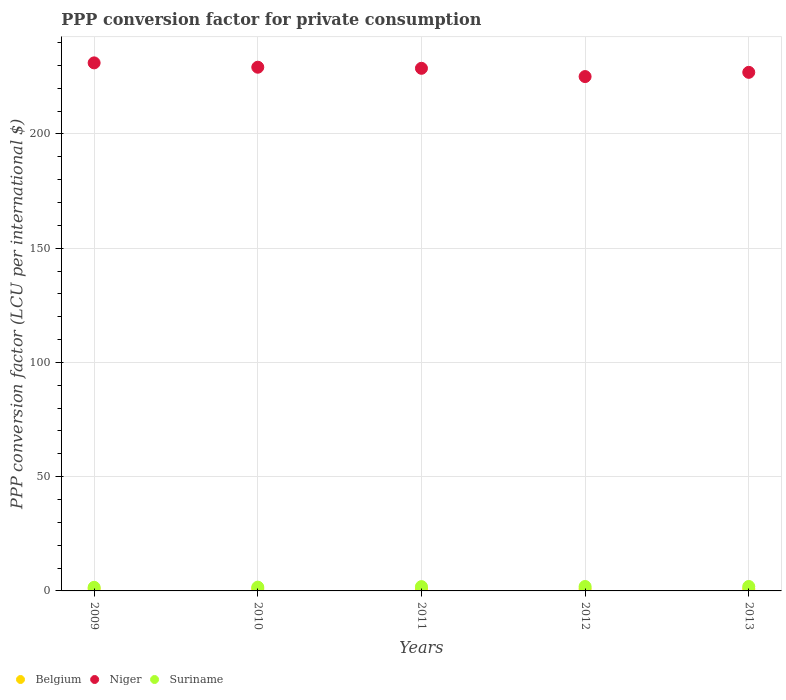Is the number of dotlines equal to the number of legend labels?
Your answer should be very brief. Yes. What is the PPP conversion factor for private consumption in Niger in 2012?
Offer a very short reply. 225.14. Across all years, what is the maximum PPP conversion factor for private consumption in Suriname?
Your answer should be very brief. 1.95. Across all years, what is the minimum PPP conversion factor for private consumption in Niger?
Your answer should be compact. 225.14. In which year was the PPP conversion factor for private consumption in Niger maximum?
Keep it short and to the point. 2009. What is the total PPP conversion factor for private consumption in Suriname in the graph?
Provide a short and direct response. 8.99. What is the difference between the PPP conversion factor for private consumption in Belgium in 2012 and that in 2013?
Ensure brevity in your answer.  -0.01. What is the difference between the PPP conversion factor for private consumption in Belgium in 2012 and the PPP conversion factor for private consumption in Niger in 2010?
Provide a succinct answer. -228.34. What is the average PPP conversion factor for private consumption in Suriname per year?
Offer a very short reply. 1.8. In the year 2011, what is the difference between the PPP conversion factor for private consumption in Belgium and PPP conversion factor for private consumption in Suriname?
Provide a short and direct response. -0.99. In how many years, is the PPP conversion factor for private consumption in Niger greater than 230 LCU?
Your answer should be very brief. 1. What is the ratio of the PPP conversion factor for private consumption in Belgium in 2009 to that in 2010?
Make the answer very short. 1. Is the PPP conversion factor for private consumption in Belgium in 2012 less than that in 2013?
Keep it short and to the point. Yes. Is the difference between the PPP conversion factor for private consumption in Belgium in 2009 and 2013 greater than the difference between the PPP conversion factor for private consumption in Suriname in 2009 and 2013?
Keep it short and to the point. Yes. What is the difference between the highest and the second highest PPP conversion factor for private consumption in Suriname?
Offer a very short reply. 0.01. What is the difference between the highest and the lowest PPP conversion factor for private consumption in Niger?
Keep it short and to the point. 6. In how many years, is the PPP conversion factor for private consumption in Niger greater than the average PPP conversion factor for private consumption in Niger taken over all years?
Your answer should be compact. 3. Is the sum of the PPP conversion factor for private consumption in Suriname in 2011 and 2013 greater than the maximum PPP conversion factor for private consumption in Belgium across all years?
Ensure brevity in your answer.  Yes. Is it the case that in every year, the sum of the PPP conversion factor for private consumption in Niger and PPP conversion factor for private consumption in Belgium  is greater than the PPP conversion factor for private consumption in Suriname?
Your answer should be compact. Yes. Does the PPP conversion factor for private consumption in Suriname monotonically increase over the years?
Your answer should be very brief. Yes. Is the PPP conversion factor for private consumption in Belgium strictly greater than the PPP conversion factor for private consumption in Suriname over the years?
Give a very brief answer. No. Is the PPP conversion factor for private consumption in Suriname strictly less than the PPP conversion factor for private consumption in Niger over the years?
Your answer should be compact. Yes. What is the difference between two consecutive major ticks on the Y-axis?
Give a very brief answer. 50. Are the values on the major ticks of Y-axis written in scientific E-notation?
Your answer should be compact. No. What is the title of the graph?
Keep it short and to the point. PPP conversion factor for private consumption. Does "World" appear as one of the legend labels in the graph?
Make the answer very short. No. What is the label or title of the Y-axis?
Offer a very short reply. PPP conversion factor (LCU per international $). What is the PPP conversion factor (LCU per international $) in Belgium in 2009?
Offer a terse response. 0.9. What is the PPP conversion factor (LCU per international $) in Niger in 2009?
Make the answer very short. 231.13. What is the PPP conversion factor (LCU per international $) of Suriname in 2009?
Keep it short and to the point. 1.57. What is the PPP conversion factor (LCU per international $) of Belgium in 2010?
Offer a terse response. 0.9. What is the PPP conversion factor (LCU per international $) in Niger in 2010?
Provide a succinct answer. 229.23. What is the PPP conversion factor (LCU per international $) in Suriname in 2010?
Your answer should be very brief. 1.65. What is the PPP conversion factor (LCU per international $) of Belgium in 2011?
Ensure brevity in your answer.  0.89. What is the PPP conversion factor (LCU per international $) in Niger in 2011?
Provide a short and direct response. 228.75. What is the PPP conversion factor (LCU per international $) of Suriname in 2011?
Provide a short and direct response. 1.88. What is the PPP conversion factor (LCU per international $) of Belgium in 2012?
Your answer should be very brief. 0.89. What is the PPP conversion factor (LCU per international $) of Niger in 2012?
Provide a succinct answer. 225.14. What is the PPP conversion factor (LCU per international $) of Suriname in 2012?
Your response must be concise. 1.94. What is the PPP conversion factor (LCU per international $) of Belgium in 2013?
Make the answer very short. 0.9. What is the PPP conversion factor (LCU per international $) of Niger in 2013?
Give a very brief answer. 226.99. What is the PPP conversion factor (LCU per international $) of Suriname in 2013?
Your response must be concise. 1.95. Across all years, what is the maximum PPP conversion factor (LCU per international $) in Belgium?
Provide a succinct answer. 0.9. Across all years, what is the maximum PPP conversion factor (LCU per international $) in Niger?
Keep it short and to the point. 231.13. Across all years, what is the maximum PPP conversion factor (LCU per international $) in Suriname?
Offer a terse response. 1.95. Across all years, what is the minimum PPP conversion factor (LCU per international $) in Belgium?
Your response must be concise. 0.89. Across all years, what is the minimum PPP conversion factor (LCU per international $) of Niger?
Offer a very short reply. 225.14. Across all years, what is the minimum PPP conversion factor (LCU per international $) of Suriname?
Keep it short and to the point. 1.57. What is the total PPP conversion factor (LCU per international $) of Belgium in the graph?
Your response must be concise. 4.48. What is the total PPP conversion factor (LCU per international $) of Niger in the graph?
Keep it short and to the point. 1141.23. What is the total PPP conversion factor (LCU per international $) of Suriname in the graph?
Your answer should be compact. 8.99. What is the difference between the PPP conversion factor (LCU per international $) of Belgium in 2009 and that in 2010?
Your answer should be compact. -0. What is the difference between the PPP conversion factor (LCU per international $) in Niger in 2009 and that in 2010?
Your response must be concise. 1.9. What is the difference between the PPP conversion factor (LCU per international $) in Suriname in 2009 and that in 2010?
Give a very brief answer. -0.08. What is the difference between the PPP conversion factor (LCU per international $) of Belgium in 2009 and that in 2011?
Offer a very short reply. 0.01. What is the difference between the PPP conversion factor (LCU per international $) of Niger in 2009 and that in 2011?
Make the answer very short. 2.38. What is the difference between the PPP conversion factor (LCU per international $) in Suriname in 2009 and that in 2011?
Offer a terse response. -0.32. What is the difference between the PPP conversion factor (LCU per international $) of Belgium in 2009 and that in 2012?
Offer a terse response. 0.01. What is the difference between the PPP conversion factor (LCU per international $) in Niger in 2009 and that in 2012?
Your response must be concise. 6. What is the difference between the PPP conversion factor (LCU per international $) in Suriname in 2009 and that in 2012?
Offer a very short reply. -0.37. What is the difference between the PPP conversion factor (LCU per international $) of Belgium in 2009 and that in 2013?
Offer a terse response. 0. What is the difference between the PPP conversion factor (LCU per international $) of Niger in 2009 and that in 2013?
Give a very brief answer. 4.15. What is the difference between the PPP conversion factor (LCU per international $) of Suriname in 2009 and that in 2013?
Make the answer very short. -0.38. What is the difference between the PPP conversion factor (LCU per international $) of Belgium in 2010 and that in 2011?
Ensure brevity in your answer.  0.01. What is the difference between the PPP conversion factor (LCU per international $) of Niger in 2010 and that in 2011?
Your response must be concise. 0.48. What is the difference between the PPP conversion factor (LCU per international $) of Suriname in 2010 and that in 2011?
Offer a terse response. -0.23. What is the difference between the PPP conversion factor (LCU per international $) of Belgium in 2010 and that in 2012?
Make the answer very short. 0.01. What is the difference between the PPP conversion factor (LCU per international $) in Niger in 2010 and that in 2012?
Keep it short and to the point. 4.09. What is the difference between the PPP conversion factor (LCU per international $) in Suriname in 2010 and that in 2012?
Offer a very short reply. -0.29. What is the difference between the PPP conversion factor (LCU per international $) in Belgium in 2010 and that in 2013?
Ensure brevity in your answer.  0.01. What is the difference between the PPP conversion factor (LCU per international $) of Niger in 2010 and that in 2013?
Ensure brevity in your answer.  2.24. What is the difference between the PPP conversion factor (LCU per international $) in Suriname in 2010 and that in 2013?
Provide a succinct answer. -0.3. What is the difference between the PPP conversion factor (LCU per international $) in Belgium in 2011 and that in 2012?
Give a very brief answer. -0. What is the difference between the PPP conversion factor (LCU per international $) of Niger in 2011 and that in 2012?
Make the answer very short. 3.62. What is the difference between the PPP conversion factor (LCU per international $) of Suriname in 2011 and that in 2012?
Offer a terse response. -0.05. What is the difference between the PPP conversion factor (LCU per international $) of Belgium in 2011 and that in 2013?
Ensure brevity in your answer.  -0.01. What is the difference between the PPP conversion factor (LCU per international $) of Niger in 2011 and that in 2013?
Provide a short and direct response. 1.77. What is the difference between the PPP conversion factor (LCU per international $) of Suriname in 2011 and that in 2013?
Ensure brevity in your answer.  -0.06. What is the difference between the PPP conversion factor (LCU per international $) in Belgium in 2012 and that in 2013?
Offer a very short reply. -0.01. What is the difference between the PPP conversion factor (LCU per international $) in Niger in 2012 and that in 2013?
Provide a succinct answer. -1.85. What is the difference between the PPP conversion factor (LCU per international $) in Suriname in 2012 and that in 2013?
Your answer should be very brief. -0.01. What is the difference between the PPP conversion factor (LCU per international $) in Belgium in 2009 and the PPP conversion factor (LCU per international $) in Niger in 2010?
Ensure brevity in your answer.  -228.33. What is the difference between the PPP conversion factor (LCU per international $) in Belgium in 2009 and the PPP conversion factor (LCU per international $) in Suriname in 2010?
Give a very brief answer. -0.75. What is the difference between the PPP conversion factor (LCU per international $) in Niger in 2009 and the PPP conversion factor (LCU per international $) in Suriname in 2010?
Give a very brief answer. 229.48. What is the difference between the PPP conversion factor (LCU per international $) of Belgium in 2009 and the PPP conversion factor (LCU per international $) of Niger in 2011?
Offer a terse response. -227.85. What is the difference between the PPP conversion factor (LCU per international $) in Belgium in 2009 and the PPP conversion factor (LCU per international $) in Suriname in 2011?
Make the answer very short. -0.98. What is the difference between the PPP conversion factor (LCU per international $) of Niger in 2009 and the PPP conversion factor (LCU per international $) of Suriname in 2011?
Keep it short and to the point. 229.25. What is the difference between the PPP conversion factor (LCU per international $) in Belgium in 2009 and the PPP conversion factor (LCU per international $) in Niger in 2012?
Make the answer very short. -224.24. What is the difference between the PPP conversion factor (LCU per international $) in Belgium in 2009 and the PPP conversion factor (LCU per international $) in Suriname in 2012?
Your answer should be very brief. -1.04. What is the difference between the PPP conversion factor (LCU per international $) of Niger in 2009 and the PPP conversion factor (LCU per international $) of Suriname in 2012?
Your answer should be very brief. 229.19. What is the difference between the PPP conversion factor (LCU per international $) in Belgium in 2009 and the PPP conversion factor (LCU per international $) in Niger in 2013?
Offer a very short reply. -226.08. What is the difference between the PPP conversion factor (LCU per international $) in Belgium in 2009 and the PPP conversion factor (LCU per international $) in Suriname in 2013?
Give a very brief answer. -1.05. What is the difference between the PPP conversion factor (LCU per international $) of Niger in 2009 and the PPP conversion factor (LCU per international $) of Suriname in 2013?
Your answer should be very brief. 229.18. What is the difference between the PPP conversion factor (LCU per international $) of Belgium in 2010 and the PPP conversion factor (LCU per international $) of Niger in 2011?
Give a very brief answer. -227.85. What is the difference between the PPP conversion factor (LCU per international $) in Belgium in 2010 and the PPP conversion factor (LCU per international $) in Suriname in 2011?
Your answer should be very brief. -0.98. What is the difference between the PPP conversion factor (LCU per international $) in Niger in 2010 and the PPP conversion factor (LCU per international $) in Suriname in 2011?
Provide a succinct answer. 227.34. What is the difference between the PPP conversion factor (LCU per international $) of Belgium in 2010 and the PPP conversion factor (LCU per international $) of Niger in 2012?
Ensure brevity in your answer.  -224.23. What is the difference between the PPP conversion factor (LCU per international $) in Belgium in 2010 and the PPP conversion factor (LCU per international $) in Suriname in 2012?
Your answer should be very brief. -1.04. What is the difference between the PPP conversion factor (LCU per international $) of Niger in 2010 and the PPP conversion factor (LCU per international $) of Suriname in 2012?
Provide a succinct answer. 227.29. What is the difference between the PPP conversion factor (LCU per international $) of Belgium in 2010 and the PPP conversion factor (LCU per international $) of Niger in 2013?
Make the answer very short. -226.08. What is the difference between the PPP conversion factor (LCU per international $) in Belgium in 2010 and the PPP conversion factor (LCU per international $) in Suriname in 2013?
Provide a short and direct response. -1.05. What is the difference between the PPP conversion factor (LCU per international $) of Niger in 2010 and the PPP conversion factor (LCU per international $) of Suriname in 2013?
Give a very brief answer. 227.28. What is the difference between the PPP conversion factor (LCU per international $) of Belgium in 2011 and the PPP conversion factor (LCU per international $) of Niger in 2012?
Offer a very short reply. -224.24. What is the difference between the PPP conversion factor (LCU per international $) in Belgium in 2011 and the PPP conversion factor (LCU per international $) in Suriname in 2012?
Keep it short and to the point. -1.05. What is the difference between the PPP conversion factor (LCU per international $) in Niger in 2011 and the PPP conversion factor (LCU per international $) in Suriname in 2012?
Provide a short and direct response. 226.81. What is the difference between the PPP conversion factor (LCU per international $) in Belgium in 2011 and the PPP conversion factor (LCU per international $) in Niger in 2013?
Your answer should be very brief. -226.09. What is the difference between the PPP conversion factor (LCU per international $) of Belgium in 2011 and the PPP conversion factor (LCU per international $) of Suriname in 2013?
Make the answer very short. -1.06. What is the difference between the PPP conversion factor (LCU per international $) of Niger in 2011 and the PPP conversion factor (LCU per international $) of Suriname in 2013?
Your answer should be very brief. 226.8. What is the difference between the PPP conversion factor (LCU per international $) of Belgium in 2012 and the PPP conversion factor (LCU per international $) of Niger in 2013?
Give a very brief answer. -226.09. What is the difference between the PPP conversion factor (LCU per international $) in Belgium in 2012 and the PPP conversion factor (LCU per international $) in Suriname in 2013?
Your answer should be compact. -1.06. What is the difference between the PPP conversion factor (LCU per international $) of Niger in 2012 and the PPP conversion factor (LCU per international $) of Suriname in 2013?
Give a very brief answer. 223.19. What is the average PPP conversion factor (LCU per international $) of Belgium per year?
Your answer should be compact. 0.9. What is the average PPP conversion factor (LCU per international $) of Niger per year?
Make the answer very short. 228.25. What is the average PPP conversion factor (LCU per international $) in Suriname per year?
Make the answer very short. 1.8. In the year 2009, what is the difference between the PPP conversion factor (LCU per international $) of Belgium and PPP conversion factor (LCU per international $) of Niger?
Offer a terse response. -230.23. In the year 2009, what is the difference between the PPP conversion factor (LCU per international $) in Belgium and PPP conversion factor (LCU per international $) in Suriname?
Give a very brief answer. -0.67. In the year 2009, what is the difference between the PPP conversion factor (LCU per international $) of Niger and PPP conversion factor (LCU per international $) of Suriname?
Make the answer very short. 229.56. In the year 2010, what is the difference between the PPP conversion factor (LCU per international $) in Belgium and PPP conversion factor (LCU per international $) in Niger?
Keep it short and to the point. -228.33. In the year 2010, what is the difference between the PPP conversion factor (LCU per international $) of Belgium and PPP conversion factor (LCU per international $) of Suriname?
Provide a succinct answer. -0.75. In the year 2010, what is the difference between the PPP conversion factor (LCU per international $) of Niger and PPP conversion factor (LCU per international $) of Suriname?
Ensure brevity in your answer.  227.58. In the year 2011, what is the difference between the PPP conversion factor (LCU per international $) in Belgium and PPP conversion factor (LCU per international $) in Niger?
Offer a terse response. -227.86. In the year 2011, what is the difference between the PPP conversion factor (LCU per international $) of Belgium and PPP conversion factor (LCU per international $) of Suriname?
Offer a terse response. -0.99. In the year 2011, what is the difference between the PPP conversion factor (LCU per international $) in Niger and PPP conversion factor (LCU per international $) in Suriname?
Make the answer very short. 226.87. In the year 2012, what is the difference between the PPP conversion factor (LCU per international $) of Belgium and PPP conversion factor (LCU per international $) of Niger?
Your answer should be very brief. -224.24. In the year 2012, what is the difference between the PPP conversion factor (LCU per international $) in Belgium and PPP conversion factor (LCU per international $) in Suriname?
Your answer should be very brief. -1.05. In the year 2012, what is the difference between the PPP conversion factor (LCU per international $) in Niger and PPP conversion factor (LCU per international $) in Suriname?
Offer a terse response. 223.2. In the year 2013, what is the difference between the PPP conversion factor (LCU per international $) of Belgium and PPP conversion factor (LCU per international $) of Niger?
Keep it short and to the point. -226.09. In the year 2013, what is the difference between the PPP conversion factor (LCU per international $) of Belgium and PPP conversion factor (LCU per international $) of Suriname?
Make the answer very short. -1.05. In the year 2013, what is the difference between the PPP conversion factor (LCU per international $) of Niger and PPP conversion factor (LCU per international $) of Suriname?
Provide a short and direct response. 225.04. What is the ratio of the PPP conversion factor (LCU per international $) in Niger in 2009 to that in 2010?
Your response must be concise. 1.01. What is the ratio of the PPP conversion factor (LCU per international $) of Suriname in 2009 to that in 2010?
Give a very brief answer. 0.95. What is the ratio of the PPP conversion factor (LCU per international $) of Belgium in 2009 to that in 2011?
Offer a terse response. 1.01. What is the ratio of the PPP conversion factor (LCU per international $) in Niger in 2009 to that in 2011?
Your answer should be very brief. 1.01. What is the ratio of the PPP conversion factor (LCU per international $) in Suriname in 2009 to that in 2011?
Ensure brevity in your answer.  0.83. What is the ratio of the PPP conversion factor (LCU per international $) in Belgium in 2009 to that in 2012?
Your answer should be very brief. 1.01. What is the ratio of the PPP conversion factor (LCU per international $) of Niger in 2009 to that in 2012?
Make the answer very short. 1.03. What is the ratio of the PPP conversion factor (LCU per international $) in Suriname in 2009 to that in 2012?
Ensure brevity in your answer.  0.81. What is the ratio of the PPP conversion factor (LCU per international $) in Niger in 2009 to that in 2013?
Provide a short and direct response. 1.02. What is the ratio of the PPP conversion factor (LCU per international $) of Suriname in 2009 to that in 2013?
Your answer should be compact. 0.81. What is the ratio of the PPP conversion factor (LCU per international $) of Belgium in 2010 to that in 2011?
Offer a terse response. 1.01. What is the ratio of the PPP conversion factor (LCU per international $) of Niger in 2010 to that in 2011?
Offer a terse response. 1. What is the ratio of the PPP conversion factor (LCU per international $) in Suriname in 2010 to that in 2011?
Give a very brief answer. 0.88. What is the ratio of the PPP conversion factor (LCU per international $) in Belgium in 2010 to that in 2012?
Make the answer very short. 1.01. What is the ratio of the PPP conversion factor (LCU per international $) of Niger in 2010 to that in 2012?
Provide a succinct answer. 1.02. What is the ratio of the PPP conversion factor (LCU per international $) in Suriname in 2010 to that in 2012?
Provide a short and direct response. 0.85. What is the ratio of the PPP conversion factor (LCU per international $) in Niger in 2010 to that in 2013?
Offer a very short reply. 1.01. What is the ratio of the PPP conversion factor (LCU per international $) in Suriname in 2010 to that in 2013?
Offer a very short reply. 0.85. What is the ratio of the PPP conversion factor (LCU per international $) of Niger in 2011 to that in 2012?
Offer a terse response. 1.02. What is the ratio of the PPP conversion factor (LCU per international $) of Belgium in 2011 to that in 2013?
Ensure brevity in your answer.  0.99. What is the ratio of the PPP conversion factor (LCU per international $) of Niger in 2011 to that in 2013?
Your answer should be very brief. 1.01. What is the ratio of the PPP conversion factor (LCU per international $) in Suriname in 2011 to that in 2013?
Give a very brief answer. 0.97. What is the ratio of the PPP conversion factor (LCU per international $) in Belgium in 2012 to that in 2013?
Offer a terse response. 0.99. What is the ratio of the PPP conversion factor (LCU per international $) of Niger in 2012 to that in 2013?
Your answer should be compact. 0.99. What is the ratio of the PPP conversion factor (LCU per international $) of Suriname in 2012 to that in 2013?
Your answer should be very brief. 1. What is the difference between the highest and the second highest PPP conversion factor (LCU per international $) in Belgium?
Your answer should be compact. 0. What is the difference between the highest and the second highest PPP conversion factor (LCU per international $) of Niger?
Provide a succinct answer. 1.9. What is the difference between the highest and the second highest PPP conversion factor (LCU per international $) of Suriname?
Offer a very short reply. 0.01. What is the difference between the highest and the lowest PPP conversion factor (LCU per international $) of Belgium?
Your answer should be very brief. 0.01. What is the difference between the highest and the lowest PPP conversion factor (LCU per international $) of Niger?
Your answer should be very brief. 6. What is the difference between the highest and the lowest PPP conversion factor (LCU per international $) in Suriname?
Make the answer very short. 0.38. 